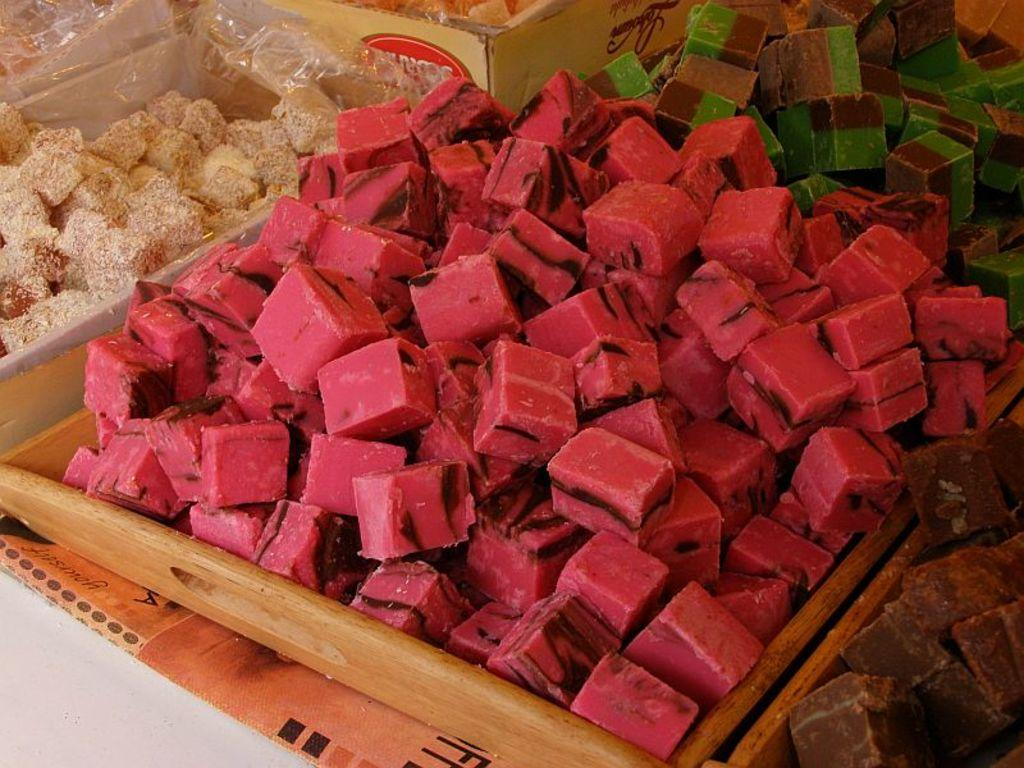What type of containers are present in the image? There are boxes and a wooden tray containing sweets in the image. What are the contents of the containers? The containers hold sweets in various colors, including red, brown, green, and white. How many apples can be seen on the wooden tray in the image? There are no apples present in the image; it contains sweets in boxes and a wooden tray. What type of weather condition is depicted in the image? The image does not depict any weather conditions; it focuses on the containers and sweets. 